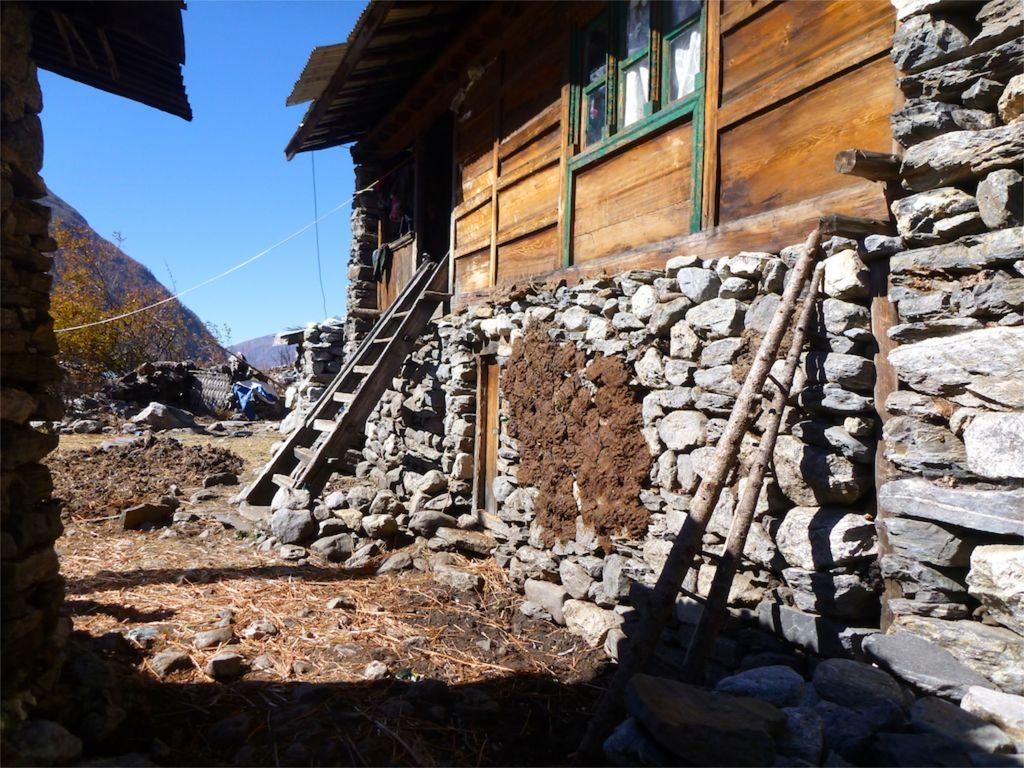What type of construction material is used for the buildings in the image? The buildings in the image are built with cobblestones. What objects can be seen in the image that might be used for climbing or reaching higher places? There are ladders in the image. What can be seen beneath the buildings and ladders in the image? The ground is visible in the image. What type of natural landscape feature is present in the image? There are hills in the image. What type of vegetation can be seen in the image? There are trees in the image. What part of the natural environment is visible in the image? The sky is visible in the image. What type of soda is being served in the image? There is no soda present in the image; it features buildings, ladders, hills, trees, and the sky. What type of cannon is visible on the hill in the image? There is no cannon present in the image; it features buildings, ladders, hills, trees, and the sky. 